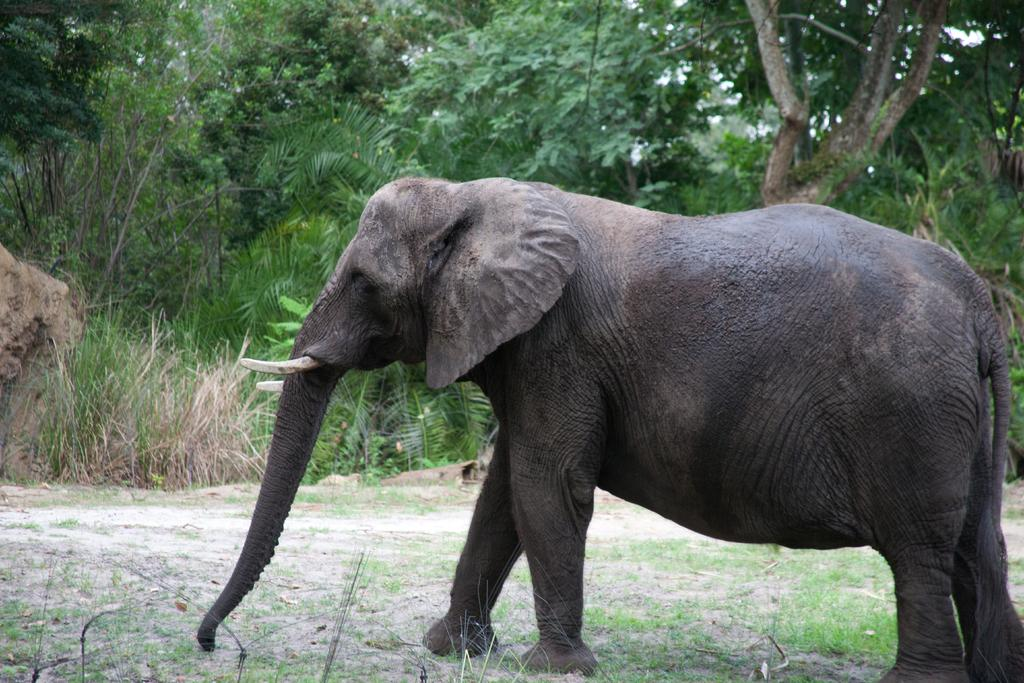What animal is the main subject of the image? There is an elephant in the image. What can be seen in the background behind the elephant? There are trees and plants behind the elephant. What does the elephant regret in the image? There is no indication in the image that the elephant is experiencing regret, as it is a still image and does not convey emotions or actions. 